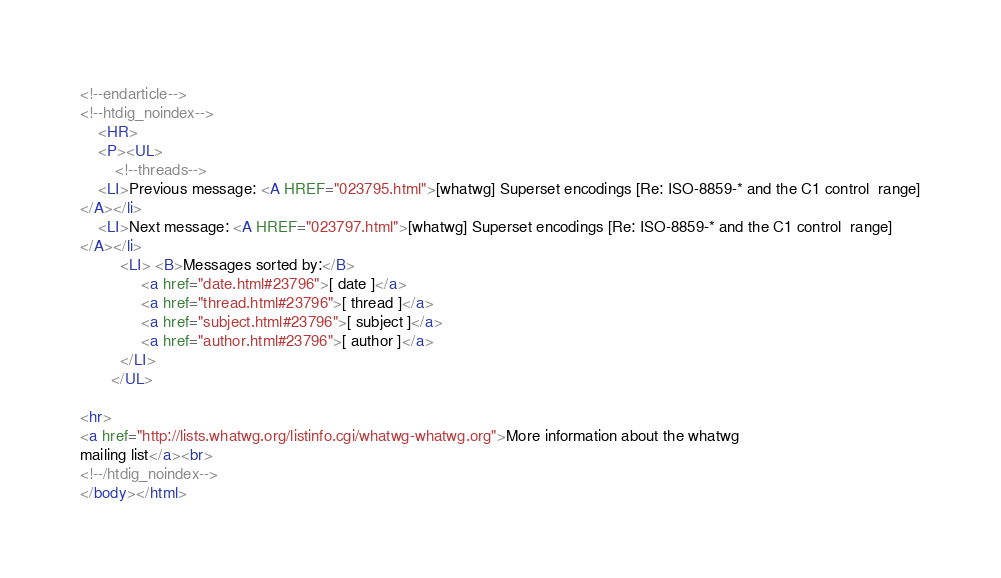<code> <loc_0><loc_0><loc_500><loc_500><_HTML_>








<!--endarticle-->
<!--htdig_noindex-->
    <HR>
    <P><UL>
        <!--threads-->
	<LI>Previous message: <A HREF="023795.html">[whatwg] Superset encodings [Re: ISO-8859-* and the C1 control	range]
</A></li>
	<LI>Next message: <A HREF="023797.html">[whatwg] Superset encodings [Re: ISO-8859-* and the C1 control	range]
</A></li>
         <LI> <B>Messages sorted by:</B> 
              <a href="date.html#23796">[ date ]</a>
              <a href="thread.html#23796">[ thread ]</a>
              <a href="subject.html#23796">[ subject ]</a>
              <a href="author.html#23796">[ author ]</a>
         </LI>
       </UL>

<hr>
<a href="http://lists.whatwg.org/listinfo.cgi/whatwg-whatwg.org">More information about the whatwg
mailing list</a><br>
<!--/htdig_noindex-->
</body></html>
</code> 